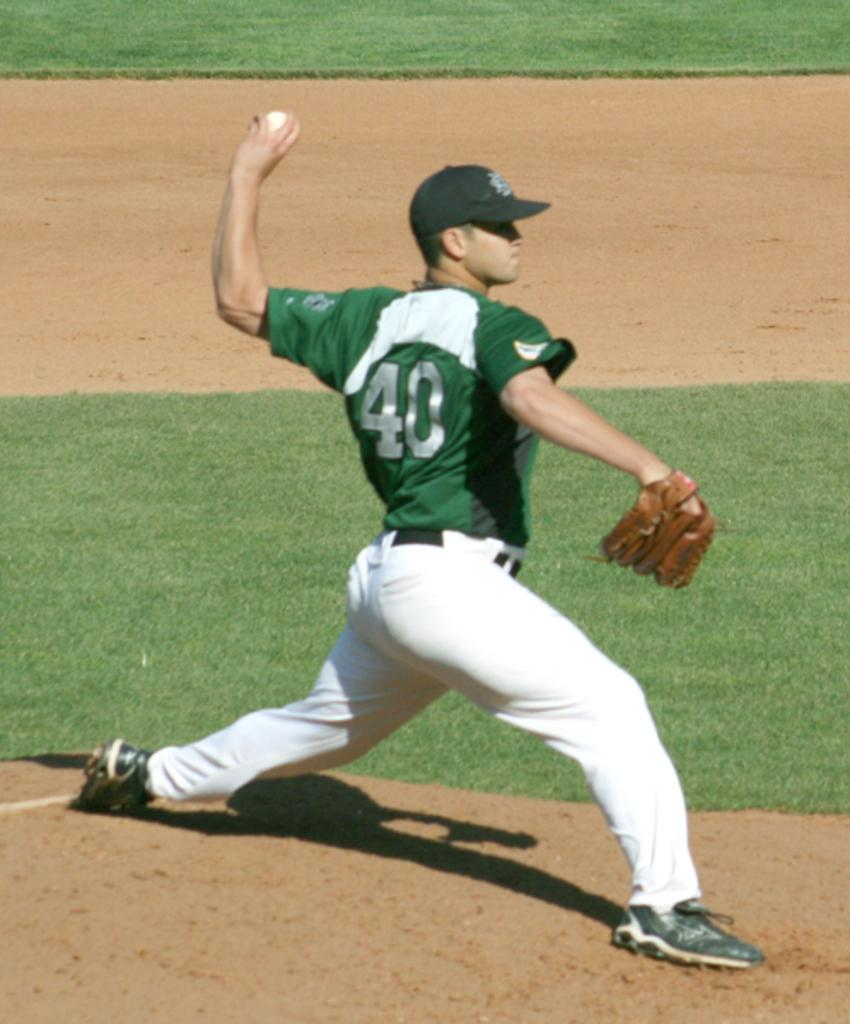<image>
Share a concise interpretation of the image provided. A baseball player with #40 on his jersey is about to throw the ball on the field. 